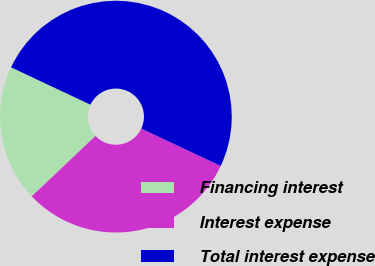<chart> <loc_0><loc_0><loc_500><loc_500><pie_chart><fcel>Financing interest<fcel>Interest expense<fcel>Total interest expense<nl><fcel>19.07%<fcel>30.93%<fcel>50.0%<nl></chart> 